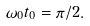<formula> <loc_0><loc_0><loc_500><loc_500>\omega _ { 0 } t _ { 0 } = \pi / 2 .</formula> 